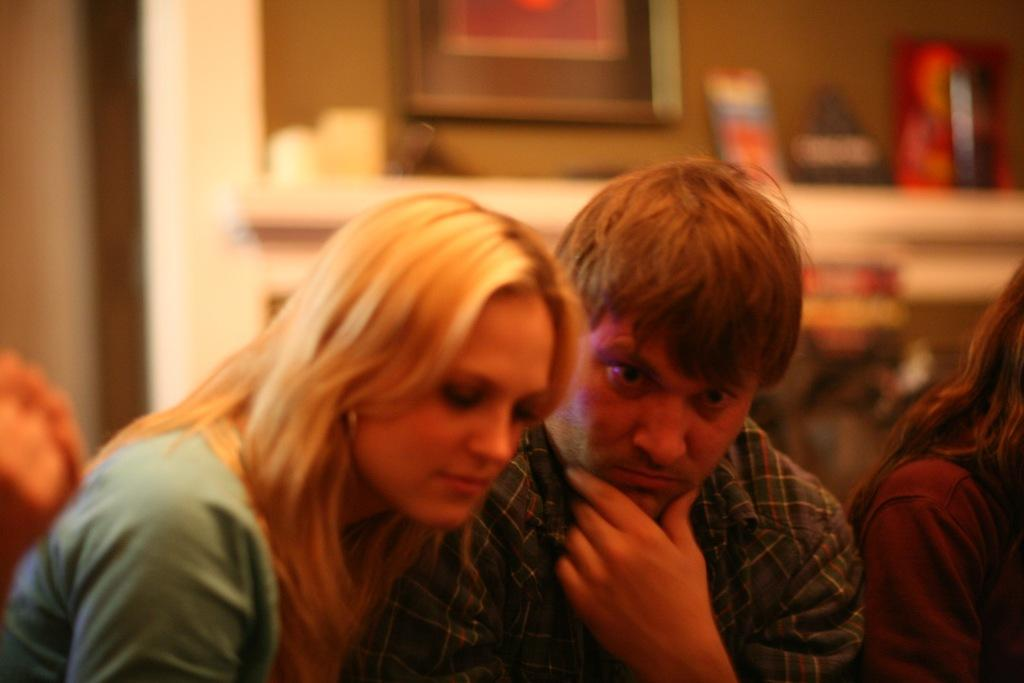What is the main focus of the image? There are people in the center of the image. How would you describe the background of the image? The background of the image is blurry. Can you identify any specific objects in the image? There is a photo frame visible in the image. What else can be observed in the image besides the people and the photo frame? There are objects present in the image. What type of song is being sung by the people in the image? There is no indication in the image that the people are singing a song, so it cannot be determined from the picture. 